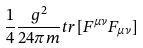<formula> <loc_0><loc_0><loc_500><loc_500>\frac { 1 } { 4 } \frac { g ^ { 2 } } { 2 4 \pi m } t r [ F ^ { \mu \nu } F _ { \mu \nu } ]</formula> 